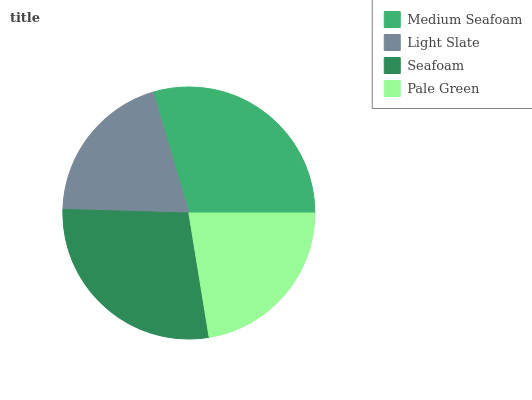Is Light Slate the minimum?
Answer yes or no. Yes. Is Medium Seafoam the maximum?
Answer yes or no. Yes. Is Seafoam the minimum?
Answer yes or no. No. Is Seafoam the maximum?
Answer yes or no. No. Is Seafoam greater than Light Slate?
Answer yes or no. Yes. Is Light Slate less than Seafoam?
Answer yes or no. Yes. Is Light Slate greater than Seafoam?
Answer yes or no. No. Is Seafoam less than Light Slate?
Answer yes or no. No. Is Seafoam the high median?
Answer yes or no. Yes. Is Pale Green the low median?
Answer yes or no. Yes. Is Medium Seafoam the high median?
Answer yes or no. No. Is Medium Seafoam the low median?
Answer yes or no. No. 